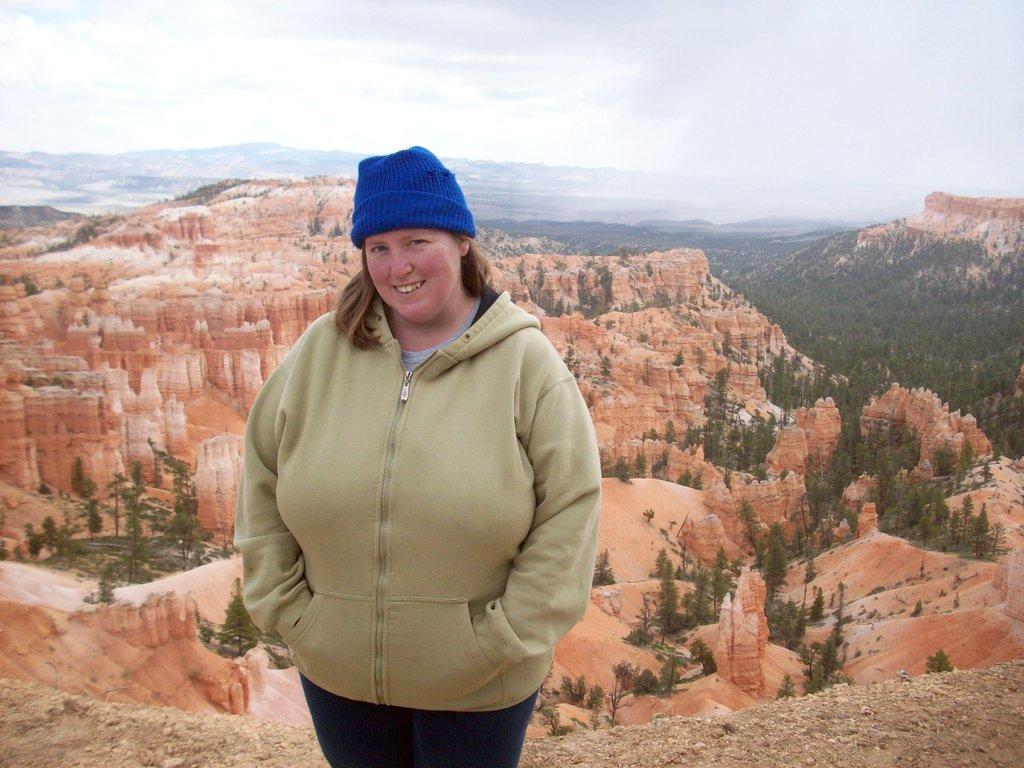How would you summarize this image in a sentence or two? In this image in the foreground there is one woman who is standing, and in the background there are mountains, trees. And at the bottom there is sand, and at the top of the image is sky. 